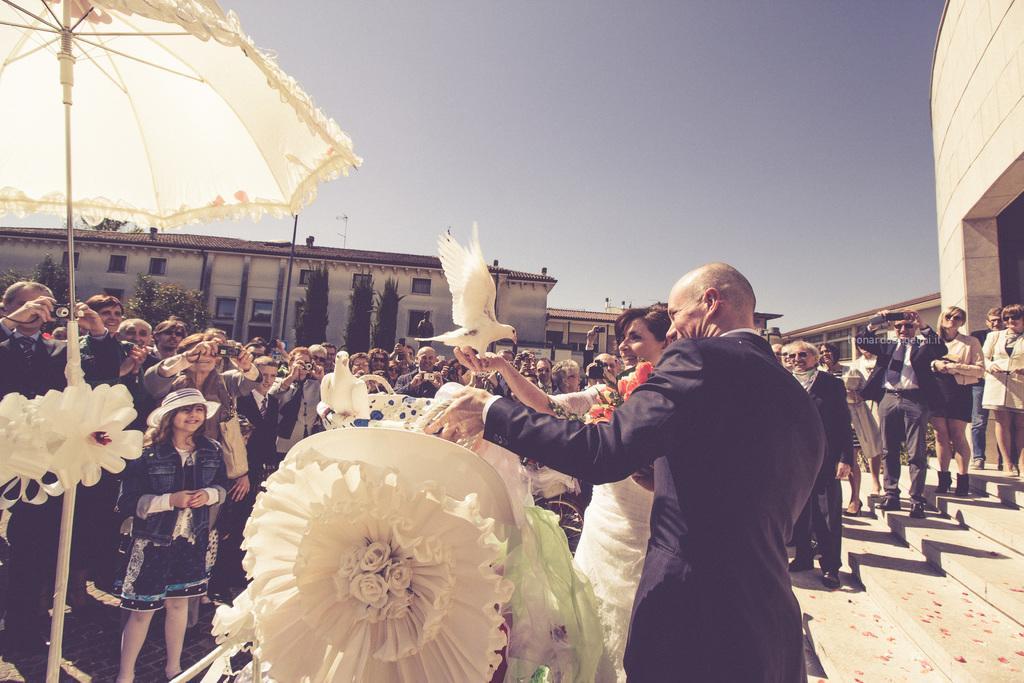Describe this image in one or two sentences. In the middle of the image there is a man standing and holding an object in his hand. Beside him there is a lady standing and holding a bird in the hand and also there are flowers. On the left side of the image there is a pole with an umbrella. Behind them there are many people standing. And there are few people with cameras in their hands. Behind them in the background there are trees, buildings and also there is sky. 